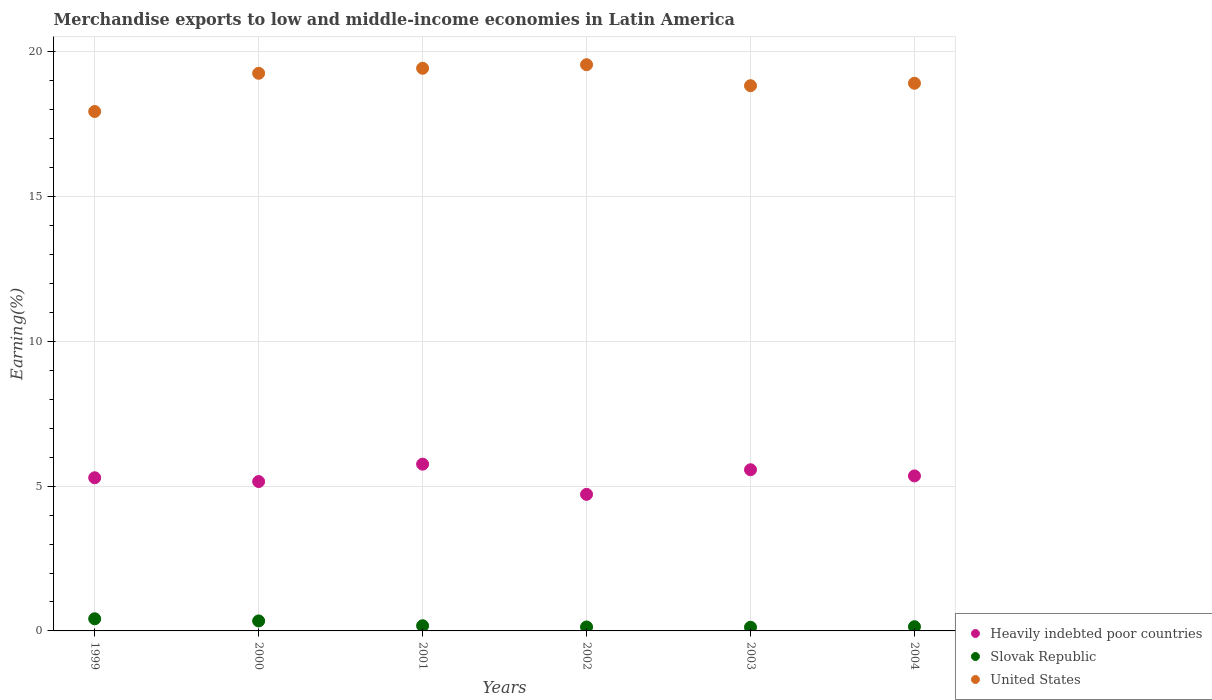How many different coloured dotlines are there?
Give a very brief answer. 3. Is the number of dotlines equal to the number of legend labels?
Give a very brief answer. Yes. What is the percentage of amount earned from merchandise exports in United States in 2002?
Your answer should be very brief. 19.56. Across all years, what is the maximum percentage of amount earned from merchandise exports in Slovak Republic?
Make the answer very short. 0.42. Across all years, what is the minimum percentage of amount earned from merchandise exports in Slovak Republic?
Your answer should be compact. 0.13. In which year was the percentage of amount earned from merchandise exports in Heavily indebted poor countries maximum?
Your answer should be compact. 2001. What is the total percentage of amount earned from merchandise exports in Heavily indebted poor countries in the graph?
Your response must be concise. 31.85. What is the difference between the percentage of amount earned from merchandise exports in Slovak Republic in 2001 and that in 2004?
Give a very brief answer. 0.03. What is the difference between the percentage of amount earned from merchandise exports in Heavily indebted poor countries in 2003 and the percentage of amount earned from merchandise exports in United States in 1999?
Make the answer very short. -12.38. What is the average percentage of amount earned from merchandise exports in Heavily indebted poor countries per year?
Make the answer very short. 5.31. In the year 2001, what is the difference between the percentage of amount earned from merchandise exports in United States and percentage of amount earned from merchandise exports in Heavily indebted poor countries?
Keep it short and to the point. 13.68. In how many years, is the percentage of amount earned from merchandise exports in Heavily indebted poor countries greater than 17 %?
Your answer should be very brief. 0. What is the ratio of the percentage of amount earned from merchandise exports in Slovak Republic in 2000 to that in 2001?
Offer a terse response. 1.93. Is the difference between the percentage of amount earned from merchandise exports in United States in 2003 and 2004 greater than the difference between the percentage of amount earned from merchandise exports in Heavily indebted poor countries in 2003 and 2004?
Make the answer very short. No. What is the difference between the highest and the second highest percentage of amount earned from merchandise exports in Slovak Republic?
Provide a short and direct response. 0.07. What is the difference between the highest and the lowest percentage of amount earned from merchandise exports in Heavily indebted poor countries?
Provide a short and direct response. 1.04. Is the percentage of amount earned from merchandise exports in United States strictly greater than the percentage of amount earned from merchandise exports in Heavily indebted poor countries over the years?
Your answer should be compact. Yes. How many dotlines are there?
Offer a terse response. 3. What is the difference between two consecutive major ticks on the Y-axis?
Provide a succinct answer. 5. How many legend labels are there?
Your answer should be very brief. 3. What is the title of the graph?
Your response must be concise. Merchandise exports to low and middle-income economies in Latin America. What is the label or title of the Y-axis?
Keep it short and to the point. Earning(%). What is the Earning(%) in Heavily indebted poor countries in 1999?
Provide a succinct answer. 5.29. What is the Earning(%) in Slovak Republic in 1999?
Ensure brevity in your answer.  0.42. What is the Earning(%) of United States in 1999?
Give a very brief answer. 17.94. What is the Earning(%) in Heavily indebted poor countries in 2000?
Your response must be concise. 5.16. What is the Earning(%) of Slovak Republic in 2000?
Make the answer very short. 0.35. What is the Earning(%) in United States in 2000?
Your answer should be very brief. 19.26. What is the Earning(%) in Heavily indebted poor countries in 2001?
Offer a terse response. 5.76. What is the Earning(%) of Slovak Republic in 2001?
Provide a short and direct response. 0.18. What is the Earning(%) of United States in 2001?
Your response must be concise. 19.44. What is the Earning(%) in Heavily indebted poor countries in 2002?
Your response must be concise. 4.72. What is the Earning(%) in Slovak Republic in 2002?
Ensure brevity in your answer.  0.14. What is the Earning(%) in United States in 2002?
Your answer should be compact. 19.56. What is the Earning(%) in Heavily indebted poor countries in 2003?
Offer a very short reply. 5.57. What is the Earning(%) of Slovak Republic in 2003?
Your answer should be very brief. 0.13. What is the Earning(%) in United States in 2003?
Your answer should be very brief. 18.84. What is the Earning(%) of Heavily indebted poor countries in 2004?
Make the answer very short. 5.36. What is the Earning(%) in Slovak Republic in 2004?
Ensure brevity in your answer.  0.15. What is the Earning(%) of United States in 2004?
Offer a terse response. 18.92. Across all years, what is the maximum Earning(%) in Heavily indebted poor countries?
Make the answer very short. 5.76. Across all years, what is the maximum Earning(%) of Slovak Republic?
Your answer should be compact. 0.42. Across all years, what is the maximum Earning(%) of United States?
Give a very brief answer. 19.56. Across all years, what is the minimum Earning(%) in Heavily indebted poor countries?
Offer a terse response. 4.72. Across all years, what is the minimum Earning(%) of Slovak Republic?
Keep it short and to the point. 0.13. Across all years, what is the minimum Earning(%) in United States?
Keep it short and to the point. 17.94. What is the total Earning(%) in Heavily indebted poor countries in the graph?
Your response must be concise. 31.85. What is the total Earning(%) in Slovak Republic in the graph?
Make the answer very short. 1.35. What is the total Earning(%) of United States in the graph?
Ensure brevity in your answer.  113.96. What is the difference between the Earning(%) in Heavily indebted poor countries in 1999 and that in 2000?
Give a very brief answer. 0.13. What is the difference between the Earning(%) of Slovak Republic in 1999 and that in 2000?
Offer a very short reply. 0.07. What is the difference between the Earning(%) of United States in 1999 and that in 2000?
Provide a short and direct response. -1.32. What is the difference between the Earning(%) of Heavily indebted poor countries in 1999 and that in 2001?
Offer a terse response. -0.47. What is the difference between the Earning(%) of Slovak Republic in 1999 and that in 2001?
Make the answer very short. 0.24. What is the difference between the Earning(%) of United States in 1999 and that in 2001?
Your answer should be very brief. -1.49. What is the difference between the Earning(%) of Heavily indebted poor countries in 1999 and that in 2002?
Ensure brevity in your answer.  0.57. What is the difference between the Earning(%) of Slovak Republic in 1999 and that in 2002?
Your answer should be very brief. 0.28. What is the difference between the Earning(%) in United States in 1999 and that in 2002?
Your response must be concise. -1.62. What is the difference between the Earning(%) of Heavily indebted poor countries in 1999 and that in 2003?
Your answer should be very brief. -0.28. What is the difference between the Earning(%) of Slovak Republic in 1999 and that in 2003?
Keep it short and to the point. 0.29. What is the difference between the Earning(%) of United States in 1999 and that in 2003?
Provide a succinct answer. -0.89. What is the difference between the Earning(%) of Heavily indebted poor countries in 1999 and that in 2004?
Your response must be concise. -0.06. What is the difference between the Earning(%) in Slovak Republic in 1999 and that in 2004?
Give a very brief answer. 0.27. What is the difference between the Earning(%) in United States in 1999 and that in 2004?
Your answer should be very brief. -0.98. What is the difference between the Earning(%) of Heavily indebted poor countries in 2000 and that in 2001?
Provide a short and direct response. -0.6. What is the difference between the Earning(%) of Slovak Republic in 2000 and that in 2001?
Your answer should be compact. 0.17. What is the difference between the Earning(%) in United States in 2000 and that in 2001?
Provide a short and direct response. -0.17. What is the difference between the Earning(%) of Heavily indebted poor countries in 2000 and that in 2002?
Your answer should be very brief. 0.44. What is the difference between the Earning(%) of Slovak Republic in 2000 and that in 2002?
Provide a short and direct response. 0.21. What is the difference between the Earning(%) of United States in 2000 and that in 2002?
Provide a succinct answer. -0.3. What is the difference between the Earning(%) in Heavily indebted poor countries in 2000 and that in 2003?
Offer a terse response. -0.41. What is the difference between the Earning(%) in Slovak Republic in 2000 and that in 2003?
Your response must be concise. 0.22. What is the difference between the Earning(%) in United States in 2000 and that in 2003?
Give a very brief answer. 0.43. What is the difference between the Earning(%) in Heavily indebted poor countries in 2000 and that in 2004?
Your answer should be very brief. -0.19. What is the difference between the Earning(%) in Slovak Republic in 2000 and that in 2004?
Ensure brevity in your answer.  0.2. What is the difference between the Earning(%) of United States in 2000 and that in 2004?
Your answer should be very brief. 0.34. What is the difference between the Earning(%) in Heavily indebted poor countries in 2001 and that in 2002?
Provide a succinct answer. 1.04. What is the difference between the Earning(%) in Slovak Republic in 2001 and that in 2002?
Your answer should be very brief. 0.04. What is the difference between the Earning(%) in United States in 2001 and that in 2002?
Your response must be concise. -0.12. What is the difference between the Earning(%) in Heavily indebted poor countries in 2001 and that in 2003?
Provide a short and direct response. 0.19. What is the difference between the Earning(%) of Slovak Republic in 2001 and that in 2003?
Your answer should be very brief. 0.05. What is the difference between the Earning(%) of United States in 2001 and that in 2003?
Ensure brevity in your answer.  0.6. What is the difference between the Earning(%) of Heavily indebted poor countries in 2001 and that in 2004?
Your response must be concise. 0.41. What is the difference between the Earning(%) in United States in 2001 and that in 2004?
Make the answer very short. 0.52. What is the difference between the Earning(%) of Heavily indebted poor countries in 2002 and that in 2003?
Your answer should be compact. -0.85. What is the difference between the Earning(%) in Slovak Republic in 2002 and that in 2003?
Your answer should be very brief. 0.01. What is the difference between the Earning(%) in United States in 2002 and that in 2003?
Keep it short and to the point. 0.73. What is the difference between the Earning(%) of Heavily indebted poor countries in 2002 and that in 2004?
Give a very brief answer. -0.64. What is the difference between the Earning(%) of Slovak Republic in 2002 and that in 2004?
Offer a very short reply. -0.01. What is the difference between the Earning(%) in United States in 2002 and that in 2004?
Your answer should be compact. 0.64. What is the difference between the Earning(%) of Heavily indebted poor countries in 2003 and that in 2004?
Provide a short and direct response. 0.21. What is the difference between the Earning(%) in Slovak Republic in 2003 and that in 2004?
Your answer should be compact. -0.02. What is the difference between the Earning(%) of United States in 2003 and that in 2004?
Offer a very short reply. -0.08. What is the difference between the Earning(%) in Heavily indebted poor countries in 1999 and the Earning(%) in Slovak Republic in 2000?
Offer a terse response. 4.95. What is the difference between the Earning(%) of Heavily indebted poor countries in 1999 and the Earning(%) of United States in 2000?
Provide a succinct answer. -13.97. What is the difference between the Earning(%) in Slovak Republic in 1999 and the Earning(%) in United States in 2000?
Your answer should be very brief. -18.84. What is the difference between the Earning(%) in Heavily indebted poor countries in 1999 and the Earning(%) in Slovak Republic in 2001?
Give a very brief answer. 5.11. What is the difference between the Earning(%) of Heavily indebted poor countries in 1999 and the Earning(%) of United States in 2001?
Provide a short and direct response. -14.15. What is the difference between the Earning(%) of Slovak Republic in 1999 and the Earning(%) of United States in 2001?
Ensure brevity in your answer.  -19.02. What is the difference between the Earning(%) in Heavily indebted poor countries in 1999 and the Earning(%) in Slovak Republic in 2002?
Offer a terse response. 5.15. What is the difference between the Earning(%) in Heavily indebted poor countries in 1999 and the Earning(%) in United States in 2002?
Give a very brief answer. -14.27. What is the difference between the Earning(%) of Slovak Republic in 1999 and the Earning(%) of United States in 2002?
Your answer should be compact. -19.14. What is the difference between the Earning(%) in Heavily indebted poor countries in 1999 and the Earning(%) in Slovak Republic in 2003?
Offer a very short reply. 5.16. What is the difference between the Earning(%) in Heavily indebted poor countries in 1999 and the Earning(%) in United States in 2003?
Your answer should be very brief. -13.54. What is the difference between the Earning(%) of Slovak Republic in 1999 and the Earning(%) of United States in 2003?
Provide a succinct answer. -18.42. What is the difference between the Earning(%) in Heavily indebted poor countries in 1999 and the Earning(%) in Slovak Republic in 2004?
Provide a succinct answer. 5.15. What is the difference between the Earning(%) of Heavily indebted poor countries in 1999 and the Earning(%) of United States in 2004?
Make the answer very short. -13.63. What is the difference between the Earning(%) of Slovak Republic in 1999 and the Earning(%) of United States in 2004?
Make the answer very short. -18.5. What is the difference between the Earning(%) of Heavily indebted poor countries in 2000 and the Earning(%) of Slovak Republic in 2001?
Your answer should be very brief. 4.98. What is the difference between the Earning(%) in Heavily indebted poor countries in 2000 and the Earning(%) in United States in 2001?
Offer a terse response. -14.28. What is the difference between the Earning(%) of Slovak Republic in 2000 and the Earning(%) of United States in 2001?
Ensure brevity in your answer.  -19.09. What is the difference between the Earning(%) of Heavily indebted poor countries in 2000 and the Earning(%) of Slovak Republic in 2002?
Provide a succinct answer. 5.02. What is the difference between the Earning(%) in Heavily indebted poor countries in 2000 and the Earning(%) in United States in 2002?
Provide a succinct answer. -14.4. What is the difference between the Earning(%) in Slovak Republic in 2000 and the Earning(%) in United States in 2002?
Make the answer very short. -19.22. What is the difference between the Earning(%) in Heavily indebted poor countries in 2000 and the Earning(%) in Slovak Republic in 2003?
Ensure brevity in your answer.  5.03. What is the difference between the Earning(%) in Heavily indebted poor countries in 2000 and the Earning(%) in United States in 2003?
Your response must be concise. -13.67. What is the difference between the Earning(%) in Slovak Republic in 2000 and the Earning(%) in United States in 2003?
Your answer should be compact. -18.49. What is the difference between the Earning(%) in Heavily indebted poor countries in 2000 and the Earning(%) in Slovak Republic in 2004?
Your answer should be very brief. 5.01. What is the difference between the Earning(%) in Heavily indebted poor countries in 2000 and the Earning(%) in United States in 2004?
Offer a terse response. -13.76. What is the difference between the Earning(%) in Slovak Republic in 2000 and the Earning(%) in United States in 2004?
Your answer should be very brief. -18.57. What is the difference between the Earning(%) of Heavily indebted poor countries in 2001 and the Earning(%) of Slovak Republic in 2002?
Ensure brevity in your answer.  5.62. What is the difference between the Earning(%) in Heavily indebted poor countries in 2001 and the Earning(%) in United States in 2002?
Your response must be concise. -13.8. What is the difference between the Earning(%) in Slovak Republic in 2001 and the Earning(%) in United States in 2002?
Offer a very short reply. -19.38. What is the difference between the Earning(%) in Heavily indebted poor countries in 2001 and the Earning(%) in Slovak Republic in 2003?
Ensure brevity in your answer.  5.63. What is the difference between the Earning(%) in Heavily indebted poor countries in 2001 and the Earning(%) in United States in 2003?
Your answer should be very brief. -13.07. What is the difference between the Earning(%) in Slovak Republic in 2001 and the Earning(%) in United States in 2003?
Ensure brevity in your answer.  -18.66. What is the difference between the Earning(%) of Heavily indebted poor countries in 2001 and the Earning(%) of Slovak Republic in 2004?
Provide a succinct answer. 5.62. What is the difference between the Earning(%) of Heavily indebted poor countries in 2001 and the Earning(%) of United States in 2004?
Your answer should be very brief. -13.16. What is the difference between the Earning(%) of Slovak Republic in 2001 and the Earning(%) of United States in 2004?
Ensure brevity in your answer.  -18.74. What is the difference between the Earning(%) in Heavily indebted poor countries in 2002 and the Earning(%) in Slovak Republic in 2003?
Give a very brief answer. 4.59. What is the difference between the Earning(%) in Heavily indebted poor countries in 2002 and the Earning(%) in United States in 2003?
Give a very brief answer. -14.12. What is the difference between the Earning(%) in Slovak Republic in 2002 and the Earning(%) in United States in 2003?
Offer a very short reply. -18.7. What is the difference between the Earning(%) in Heavily indebted poor countries in 2002 and the Earning(%) in Slovak Republic in 2004?
Your response must be concise. 4.57. What is the difference between the Earning(%) in Heavily indebted poor countries in 2002 and the Earning(%) in United States in 2004?
Offer a very short reply. -14.2. What is the difference between the Earning(%) of Slovak Republic in 2002 and the Earning(%) of United States in 2004?
Give a very brief answer. -18.78. What is the difference between the Earning(%) of Heavily indebted poor countries in 2003 and the Earning(%) of Slovak Republic in 2004?
Offer a very short reply. 5.42. What is the difference between the Earning(%) in Heavily indebted poor countries in 2003 and the Earning(%) in United States in 2004?
Your answer should be very brief. -13.35. What is the difference between the Earning(%) in Slovak Republic in 2003 and the Earning(%) in United States in 2004?
Give a very brief answer. -18.79. What is the average Earning(%) in Heavily indebted poor countries per year?
Provide a succinct answer. 5.31. What is the average Earning(%) in Slovak Republic per year?
Provide a short and direct response. 0.23. What is the average Earning(%) in United States per year?
Give a very brief answer. 18.99. In the year 1999, what is the difference between the Earning(%) in Heavily indebted poor countries and Earning(%) in Slovak Republic?
Provide a short and direct response. 4.87. In the year 1999, what is the difference between the Earning(%) of Heavily indebted poor countries and Earning(%) of United States?
Ensure brevity in your answer.  -12.65. In the year 1999, what is the difference between the Earning(%) of Slovak Republic and Earning(%) of United States?
Your answer should be compact. -17.52. In the year 2000, what is the difference between the Earning(%) in Heavily indebted poor countries and Earning(%) in Slovak Republic?
Give a very brief answer. 4.82. In the year 2000, what is the difference between the Earning(%) in Heavily indebted poor countries and Earning(%) in United States?
Provide a short and direct response. -14.1. In the year 2000, what is the difference between the Earning(%) in Slovak Republic and Earning(%) in United States?
Make the answer very short. -18.92. In the year 2001, what is the difference between the Earning(%) in Heavily indebted poor countries and Earning(%) in Slovak Republic?
Give a very brief answer. 5.58. In the year 2001, what is the difference between the Earning(%) in Heavily indebted poor countries and Earning(%) in United States?
Offer a very short reply. -13.68. In the year 2001, what is the difference between the Earning(%) in Slovak Republic and Earning(%) in United States?
Offer a terse response. -19.26. In the year 2002, what is the difference between the Earning(%) in Heavily indebted poor countries and Earning(%) in Slovak Republic?
Make the answer very short. 4.58. In the year 2002, what is the difference between the Earning(%) in Heavily indebted poor countries and Earning(%) in United States?
Make the answer very short. -14.84. In the year 2002, what is the difference between the Earning(%) of Slovak Republic and Earning(%) of United States?
Make the answer very short. -19.42. In the year 2003, what is the difference between the Earning(%) in Heavily indebted poor countries and Earning(%) in Slovak Republic?
Offer a terse response. 5.44. In the year 2003, what is the difference between the Earning(%) in Heavily indebted poor countries and Earning(%) in United States?
Your response must be concise. -13.27. In the year 2003, what is the difference between the Earning(%) of Slovak Republic and Earning(%) of United States?
Offer a terse response. -18.71. In the year 2004, what is the difference between the Earning(%) of Heavily indebted poor countries and Earning(%) of Slovak Republic?
Your response must be concise. 5.21. In the year 2004, what is the difference between the Earning(%) in Heavily indebted poor countries and Earning(%) in United States?
Your answer should be very brief. -13.56. In the year 2004, what is the difference between the Earning(%) of Slovak Republic and Earning(%) of United States?
Your answer should be compact. -18.77. What is the ratio of the Earning(%) of Heavily indebted poor countries in 1999 to that in 2000?
Provide a succinct answer. 1.03. What is the ratio of the Earning(%) in Slovak Republic in 1999 to that in 2000?
Make the answer very short. 1.21. What is the ratio of the Earning(%) in United States in 1999 to that in 2000?
Give a very brief answer. 0.93. What is the ratio of the Earning(%) in Heavily indebted poor countries in 1999 to that in 2001?
Your response must be concise. 0.92. What is the ratio of the Earning(%) in Slovak Republic in 1999 to that in 2001?
Provide a short and direct response. 2.34. What is the ratio of the Earning(%) in United States in 1999 to that in 2001?
Provide a short and direct response. 0.92. What is the ratio of the Earning(%) in Heavily indebted poor countries in 1999 to that in 2002?
Your answer should be very brief. 1.12. What is the ratio of the Earning(%) of Slovak Republic in 1999 to that in 2002?
Your answer should be compact. 3.07. What is the ratio of the Earning(%) of United States in 1999 to that in 2002?
Provide a succinct answer. 0.92. What is the ratio of the Earning(%) of Heavily indebted poor countries in 1999 to that in 2003?
Your answer should be very brief. 0.95. What is the ratio of the Earning(%) in Slovak Republic in 1999 to that in 2003?
Your answer should be very brief. 3.31. What is the ratio of the Earning(%) of United States in 1999 to that in 2003?
Offer a very short reply. 0.95. What is the ratio of the Earning(%) of Heavily indebted poor countries in 1999 to that in 2004?
Provide a succinct answer. 0.99. What is the ratio of the Earning(%) of Slovak Republic in 1999 to that in 2004?
Your answer should be compact. 2.88. What is the ratio of the Earning(%) of United States in 1999 to that in 2004?
Keep it short and to the point. 0.95. What is the ratio of the Earning(%) of Heavily indebted poor countries in 2000 to that in 2001?
Offer a very short reply. 0.9. What is the ratio of the Earning(%) in Slovak Republic in 2000 to that in 2001?
Your answer should be very brief. 1.93. What is the ratio of the Earning(%) in United States in 2000 to that in 2001?
Provide a succinct answer. 0.99. What is the ratio of the Earning(%) in Heavily indebted poor countries in 2000 to that in 2002?
Keep it short and to the point. 1.09. What is the ratio of the Earning(%) of Slovak Republic in 2000 to that in 2002?
Keep it short and to the point. 2.53. What is the ratio of the Earning(%) in United States in 2000 to that in 2002?
Provide a short and direct response. 0.98. What is the ratio of the Earning(%) in Heavily indebted poor countries in 2000 to that in 2003?
Give a very brief answer. 0.93. What is the ratio of the Earning(%) of Slovak Republic in 2000 to that in 2003?
Your answer should be very brief. 2.72. What is the ratio of the Earning(%) of United States in 2000 to that in 2003?
Keep it short and to the point. 1.02. What is the ratio of the Earning(%) of Heavily indebted poor countries in 2000 to that in 2004?
Your answer should be compact. 0.96. What is the ratio of the Earning(%) of Slovak Republic in 2000 to that in 2004?
Make the answer very short. 2.37. What is the ratio of the Earning(%) in United States in 2000 to that in 2004?
Your response must be concise. 1.02. What is the ratio of the Earning(%) of Heavily indebted poor countries in 2001 to that in 2002?
Your answer should be very brief. 1.22. What is the ratio of the Earning(%) of Slovak Republic in 2001 to that in 2002?
Offer a very short reply. 1.31. What is the ratio of the Earning(%) of United States in 2001 to that in 2002?
Provide a succinct answer. 0.99. What is the ratio of the Earning(%) in Heavily indebted poor countries in 2001 to that in 2003?
Ensure brevity in your answer.  1.03. What is the ratio of the Earning(%) in Slovak Republic in 2001 to that in 2003?
Provide a short and direct response. 1.41. What is the ratio of the Earning(%) of United States in 2001 to that in 2003?
Provide a short and direct response. 1.03. What is the ratio of the Earning(%) in Heavily indebted poor countries in 2001 to that in 2004?
Provide a short and direct response. 1.08. What is the ratio of the Earning(%) in Slovak Republic in 2001 to that in 2004?
Provide a succinct answer. 1.23. What is the ratio of the Earning(%) in United States in 2001 to that in 2004?
Keep it short and to the point. 1.03. What is the ratio of the Earning(%) of Heavily indebted poor countries in 2002 to that in 2003?
Make the answer very short. 0.85. What is the ratio of the Earning(%) of Slovak Republic in 2002 to that in 2003?
Ensure brevity in your answer.  1.08. What is the ratio of the Earning(%) of United States in 2002 to that in 2003?
Ensure brevity in your answer.  1.04. What is the ratio of the Earning(%) in Heavily indebted poor countries in 2002 to that in 2004?
Your answer should be compact. 0.88. What is the ratio of the Earning(%) in Slovak Republic in 2002 to that in 2004?
Your answer should be compact. 0.94. What is the ratio of the Earning(%) of United States in 2002 to that in 2004?
Ensure brevity in your answer.  1.03. What is the ratio of the Earning(%) in Heavily indebted poor countries in 2003 to that in 2004?
Provide a succinct answer. 1.04. What is the ratio of the Earning(%) of Slovak Republic in 2003 to that in 2004?
Provide a succinct answer. 0.87. What is the ratio of the Earning(%) of United States in 2003 to that in 2004?
Your response must be concise. 1. What is the difference between the highest and the second highest Earning(%) in Heavily indebted poor countries?
Offer a terse response. 0.19. What is the difference between the highest and the second highest Earning(%) in Slovak Republic?
Ensure brevity in your answer.  0.07. What is the difference between the highest and the second highest Earning(%) of United States?
Your response must be concise. 0.12. What is the difference between the highest and the lowest Earning(%) in Heavily indebted poor countries?
Ensure brevity in your answer.  1.04. What is the difference between the highest and the lowest Earning(%) of Slovak Republic?
Offer a terse response. 0.29. What is the difference between the highest and the lowest Earning(%) in United States?
Your response must be concise. 1.62. 